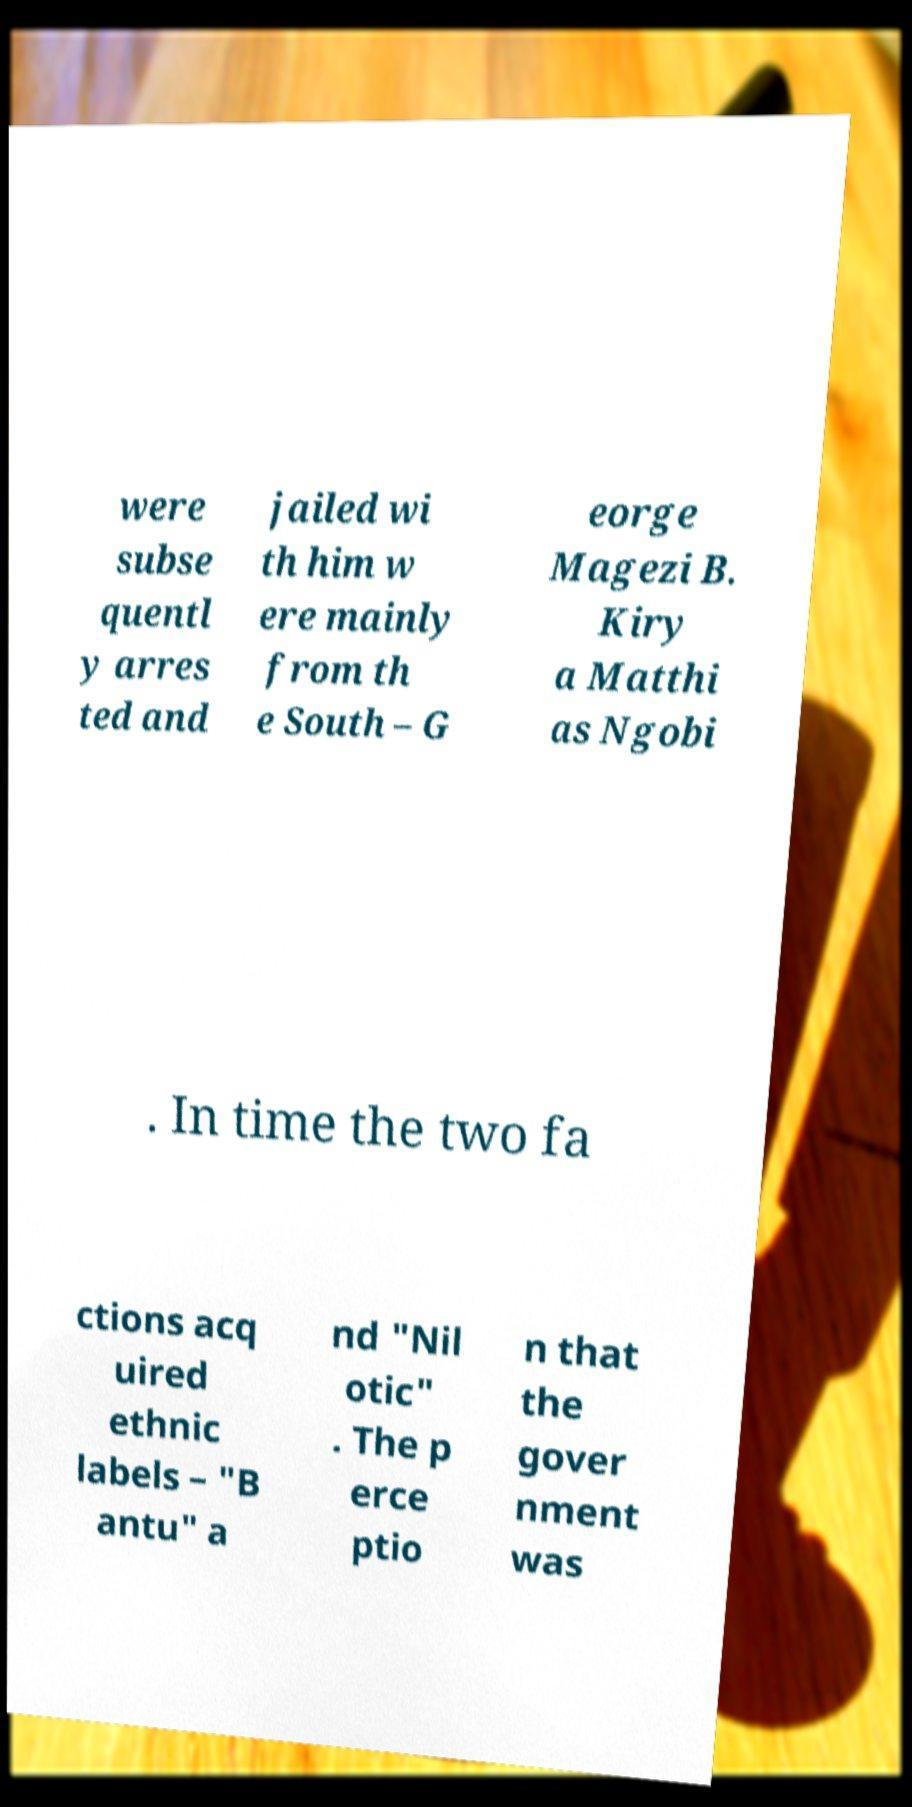Please identify and transcribe the text found in this image. were subse quentl y arres ted and jailed wi th him w ere mainly from th e South – G eorge Magezi B. Kiry a Matthi as Ngobi . In time the two fa ctions acq uired ethnic labels – "B antu" a nd "Nil otic" . The p erce ptio n that the gover nment was 